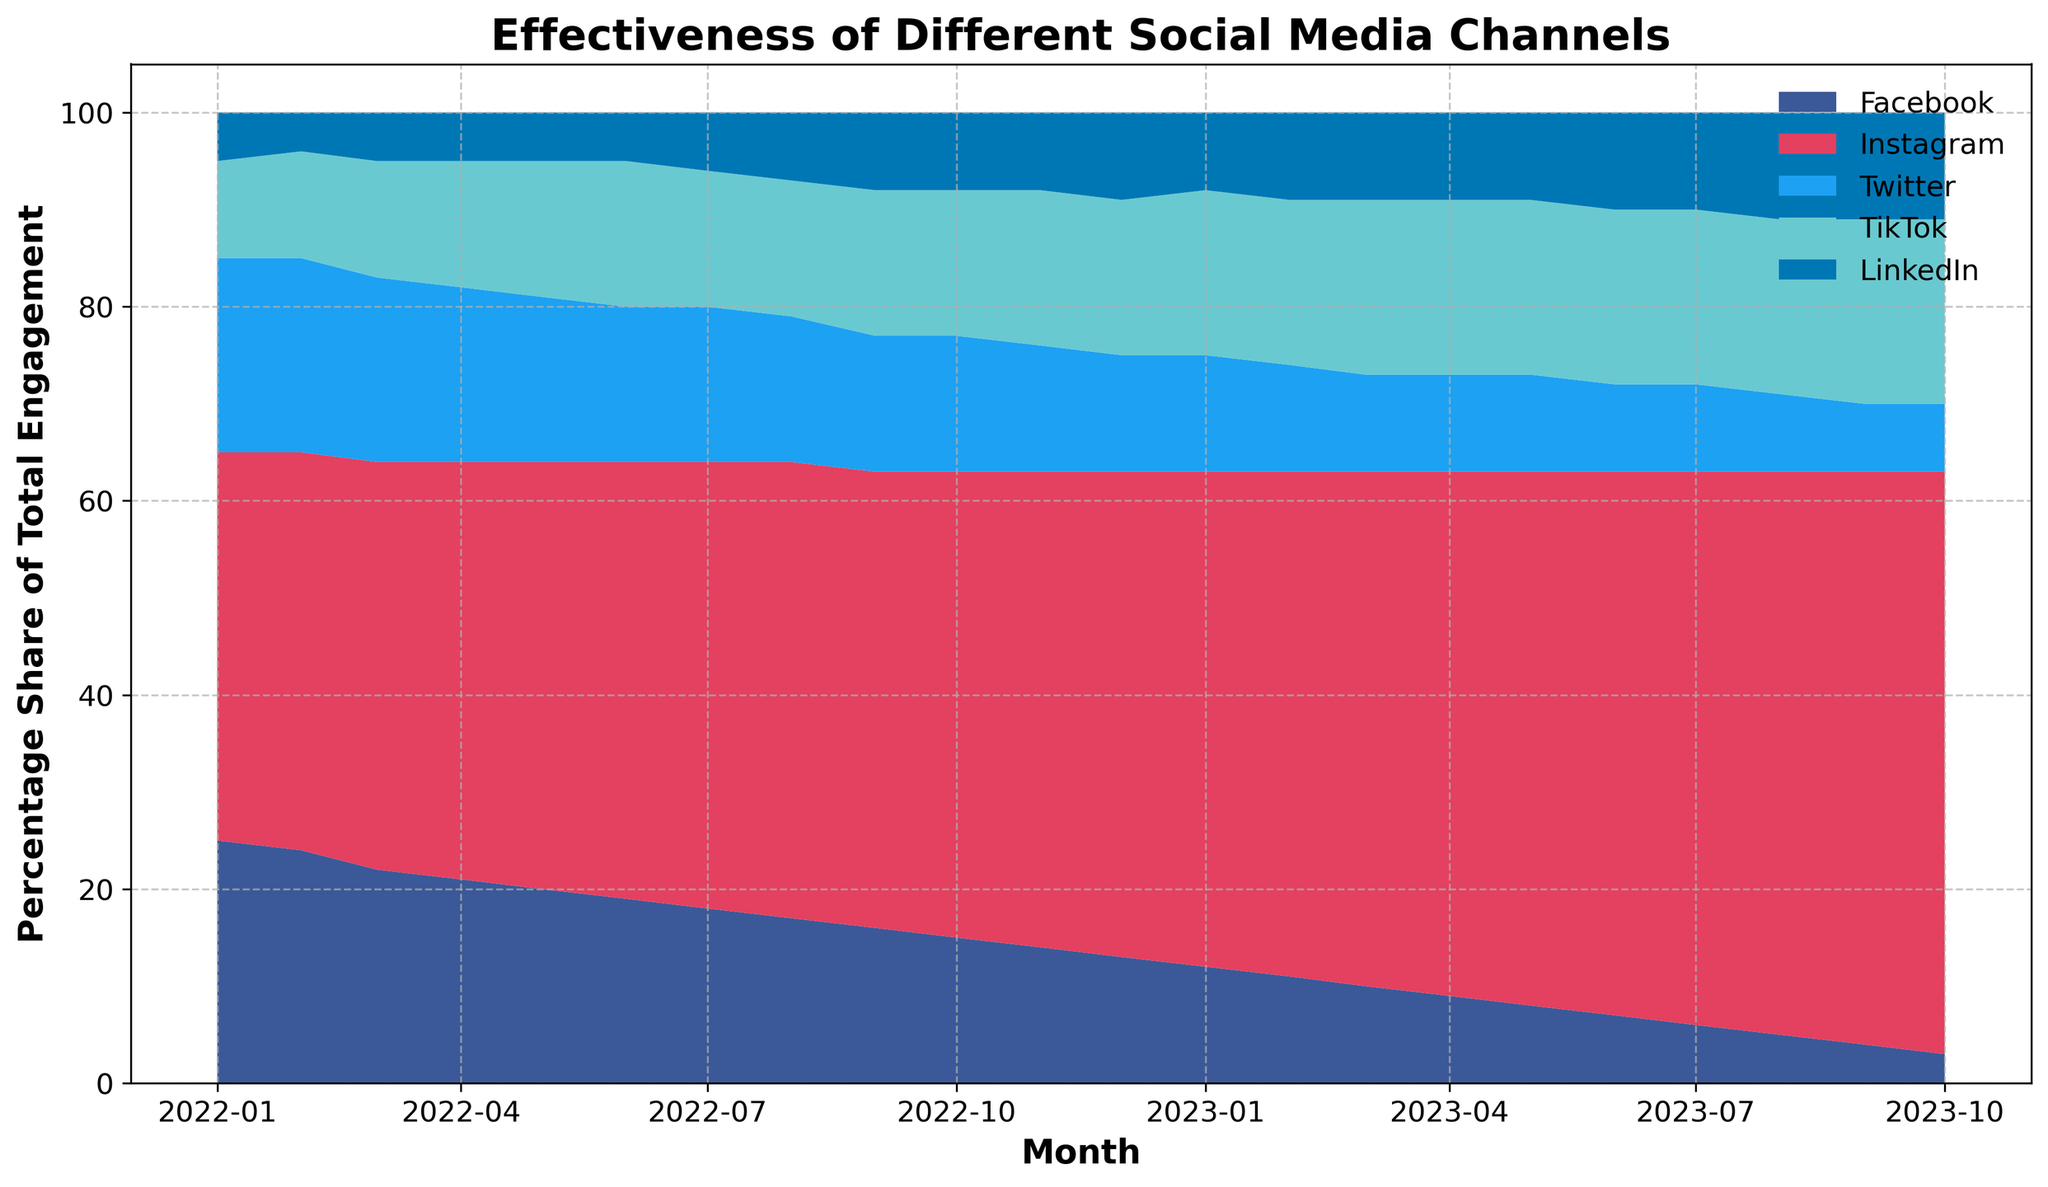What's the trend of Instagram's share of engagement over the past year? Over the months shown in the area chart, Instagram's share of engagement consistently increases from 40% at the beginning to 60% at the end. By simply tracking the heights of the Instagram area, denoted by its specific color, we can see the increase in share over the months.
Answer: Increasing trend How does TikTok's percentage share change from the beginning to the end of the year? At the beginning of the observation period (Jan 2022), TikTok's share is at 10%. By the end of the period (Oct 2023), TikTok's share has increased to 19%. Observing the area corresponding to TikTok, we see a gradual increase in the height.
Answer: It increased from 10% to 19% Which social media channel had the largest decrease in engagement share over the observed period? Looking at the area chart, Facebook's share decreased the most, from 25% in Jan 2022 to 3% by Oct 2023. The shrinking area corresponding to Facebook is the most noticeable reduction compared to other channels.
Answer: Facebook What is the combined engagement share of LinkedIn and Twitter in Oct 2023? In Oct 2023, LinkedIn's share is 11% and Twitter's share is 7%. Adding these values gives us a combined share of 18%.
Answer: 18% Between Feb 2022 and Feb 2023, which channel experienced the most growth in engagement share? Comparing the values from Feb 2022 and Feb 2023, Instagram's engagement increased the most, from 41% to 52%, a total increase of 11%. The growth in Instagram’s area is the largest among the channels within this timeframe.
Answer: Instagram Which month shows the smallest total engagement percentage for Facebook and TikTok combined? To find which month has the smallest total engagement for Facebook and TikTok combined, we look for the minimum sum of their shares across all months. For Oct 2023, Facebook is 3% and TikTok is 19%, totaling 22%, which is the smallest combined value.
Answer: October 2023 In which month does LinkedIn surpass Twitter in engagement share? LinkedIn surpasses Twitter in Sep 2022. Before this month, LinkedIn's percentage is consistently lower than Twitter's, but starting from Sep 2022, LinkedIn’s share (8%) becomes higher than Twitter's (7%).
Answer: September 2022 How has the engagement share of Facebook and Instagram together changed from Jan 2022 to Oct 2023? Initially, in Jan 2022, Facebook and Instagram together account for 65% (25% + 40%). By Oct 2023, their combined share dropped to 63% (3% + 60%). This indicates a slight decrease of 2%.
Answer: Decreased by 2% Compare the overall trends of Twitter and TikTok over the period shown. Twitter's share shows a declining trend from 20% in Jan 2022 to 7% in Oct 2023. In contrast, TikTok's share shows an increasing trend from 10% to 19% over the same period. By visual inspection, Twitter's area shrinks while TikTok's area expands over time.
Answer: Twitter decreases, TikTok increases 